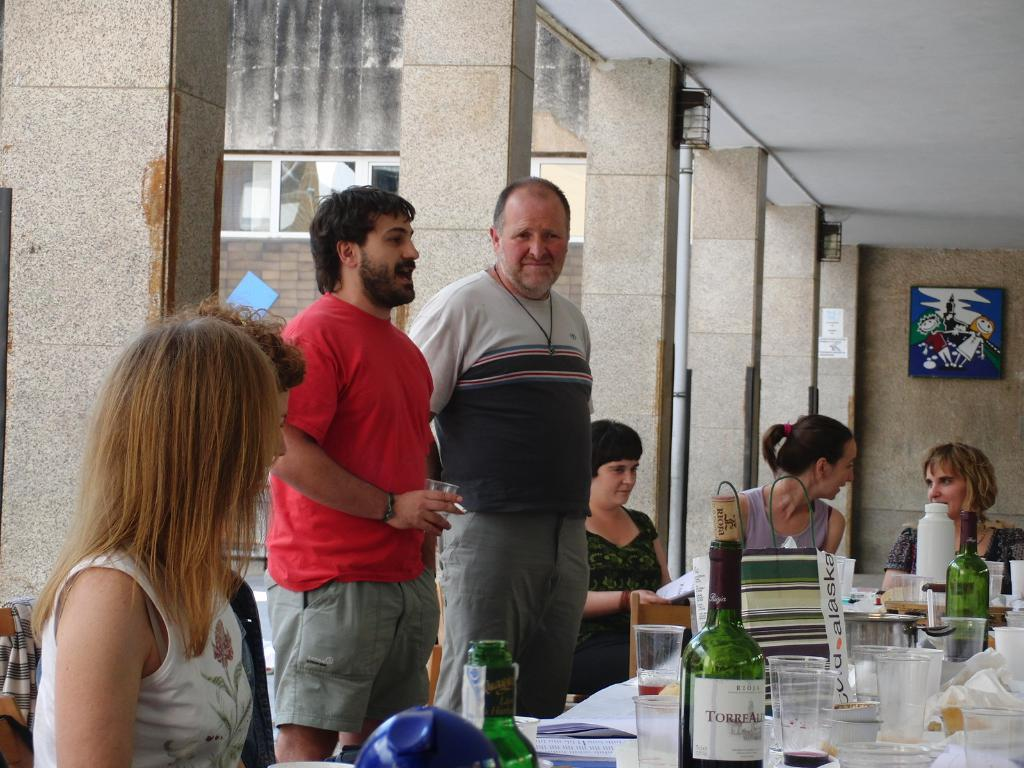How many people are in the image? There are two people standing in the image. What are the women doing in the image? There are four women sitting in the image. Where are the people and women located? They are on a floor. What furniture is present in the image? There is a table in the image. What items can be seen on the table? There are glasses and bottles on the table. What type of spark can be seen coming from the doctor's bike in the image? There is no doctor or bike present in the image, so there is no spark to be seen. 